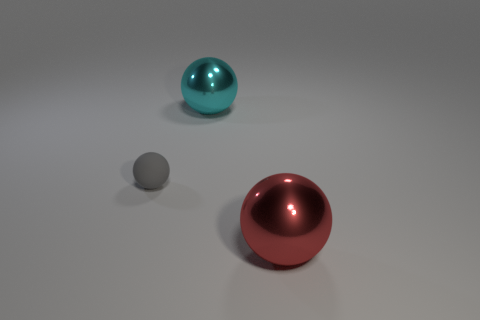There is a thing left of the large ball that is behind the tiny gray rubber object on the left side of the big red metal sphere; what is it made of?
Your response must be concise. Rubber. What size is the object that is both on the right side of the gray sphere and left of the large red shiny sphere?
Make the answer very short. Large. Is the shape of the tiny gray thing the same as the red shiny object?
Offer a terse response. Yes. There is a large cyan thing that is made of the same material as the big red object; what shape is it?
Give a very brief answer. Sphere. How many large things are either yellow rubber balls or gray things?
Offer a terse response. 0. There is a big ball behind the large red object; is there a tiny object behind it?
Make the answer very short. No. Are any large gray shiny cubes visible?
Make the answer very short. No. What is the color of the metallic sphere in front of the tiny matte thing behind the big red metallic thing?
Your answer should be compact. Red. What is the material of the gray object that is the same shape as the big red object?
Provide a succinct answer. Rubber. What number of cyan shiny spheres are the same size as the red sphere?
Your answer should be compact. 1. 